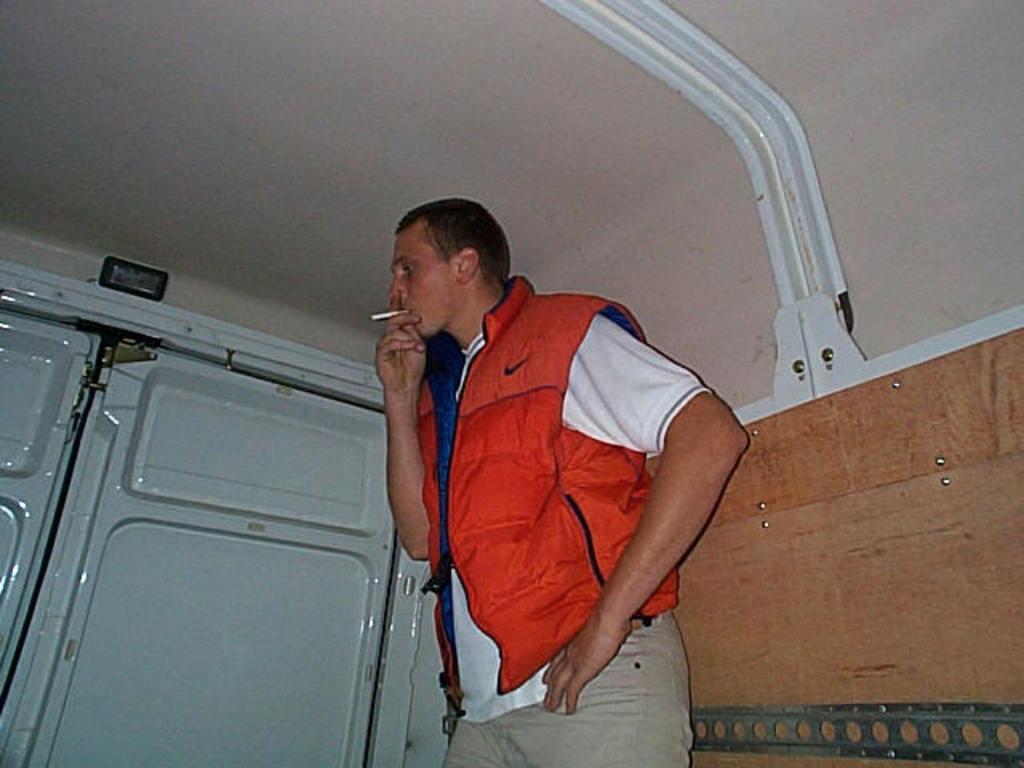How would you summarize this image in a sentence or two? In this image there is a man standing wearing orange jacket is smoking, beside him there is a white door. 